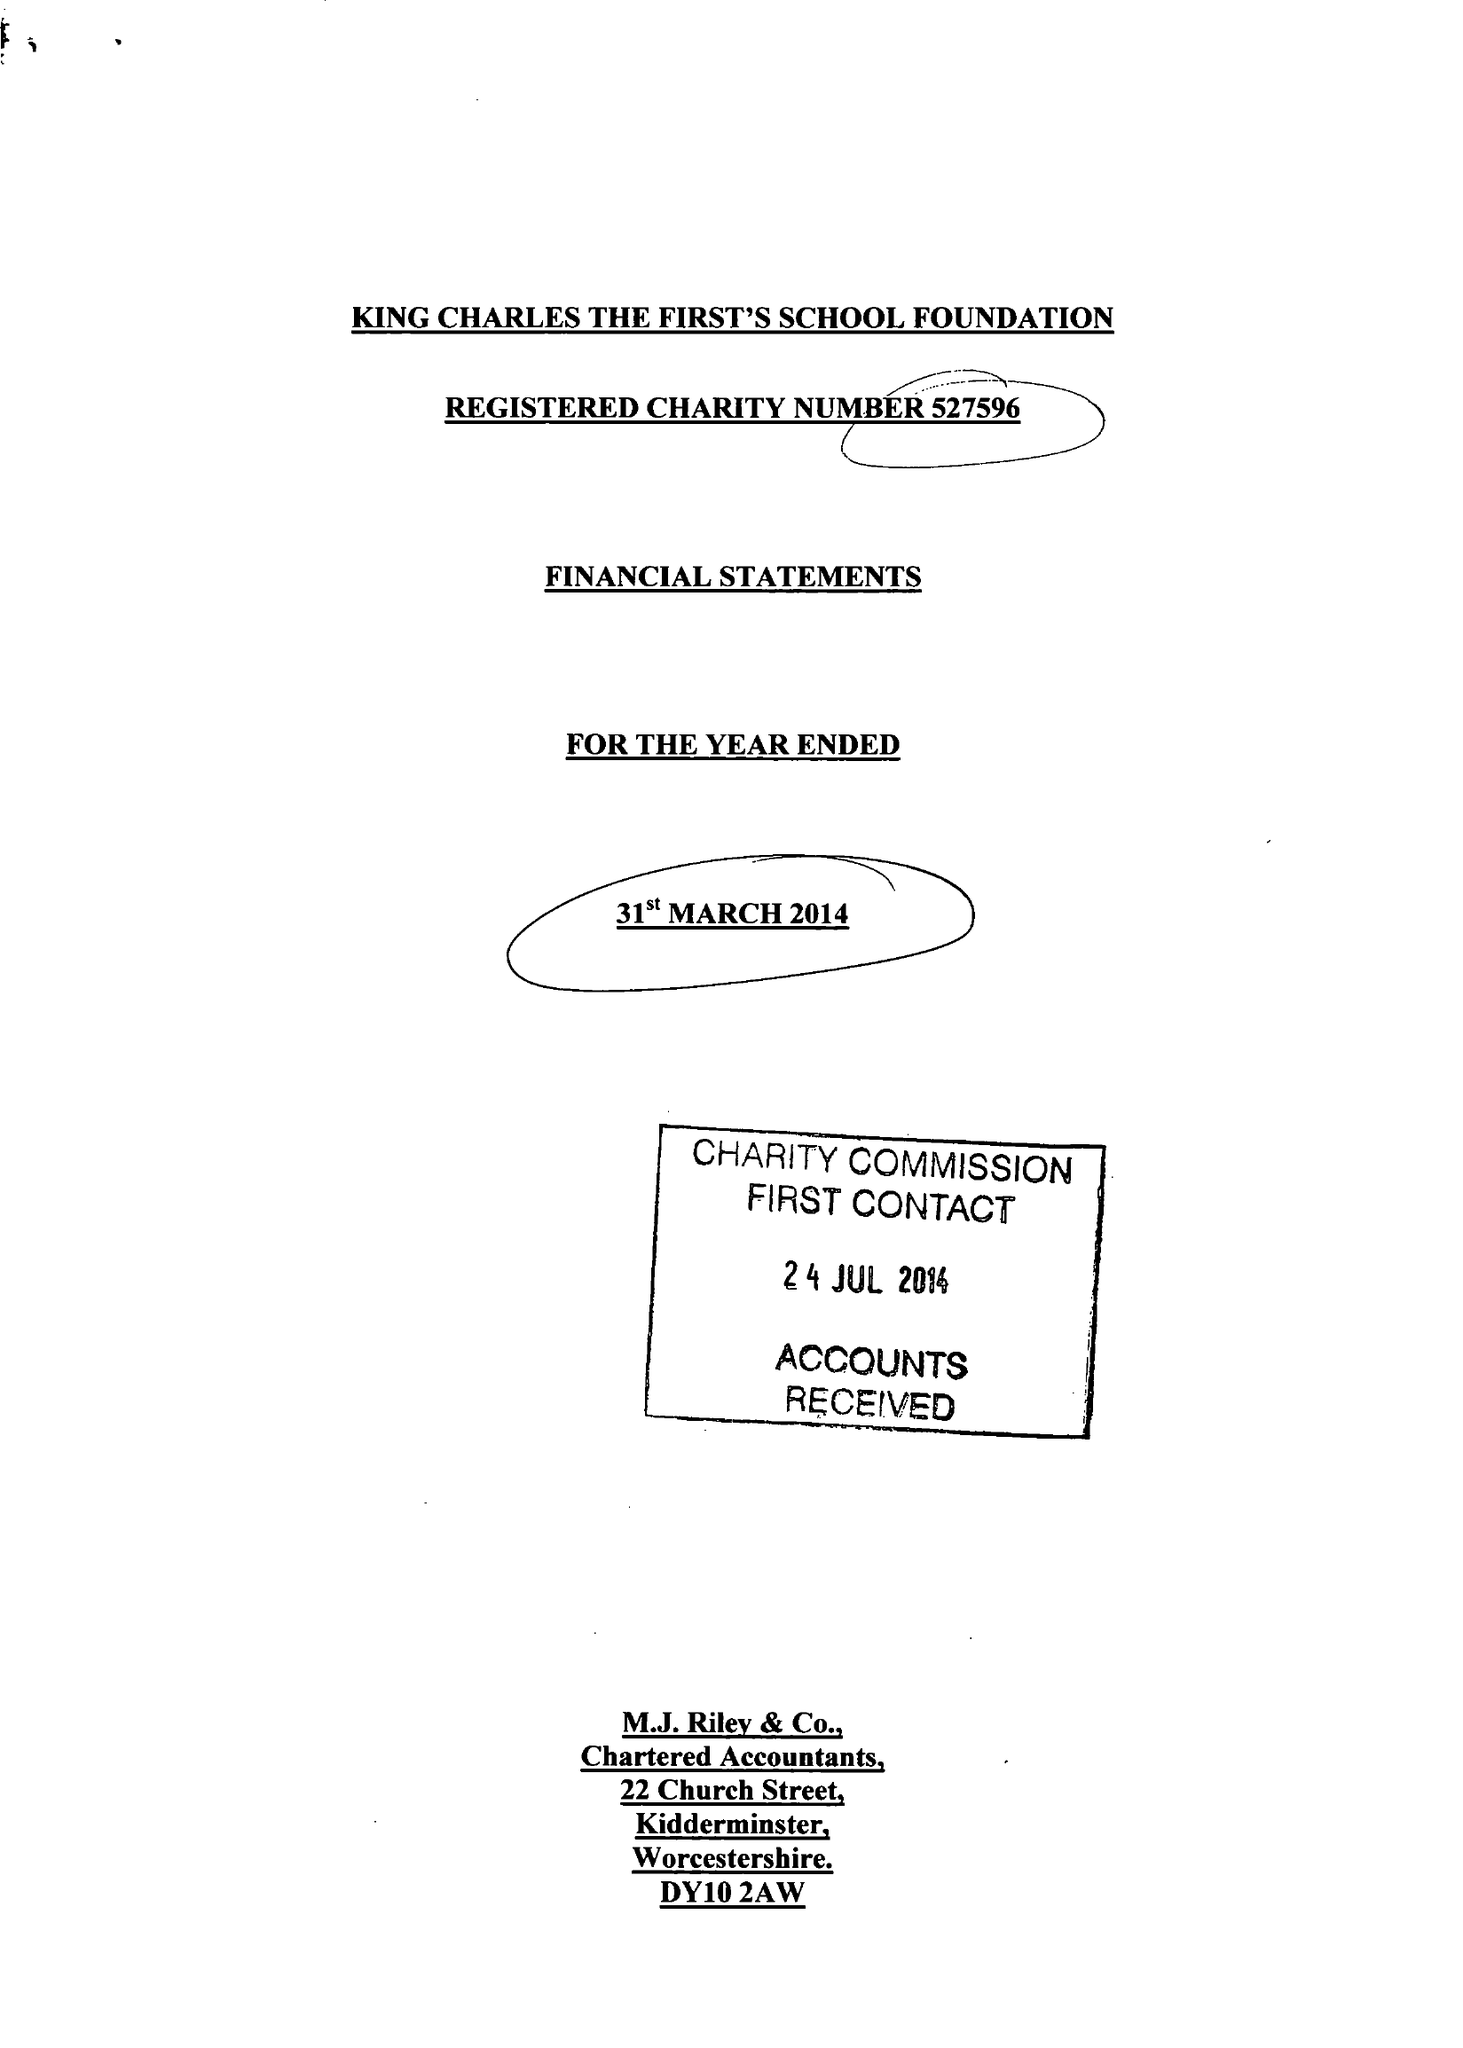What is the value for the charity_name?
Answer the question using a single word or phrase. King Charles The First's School Foundation 